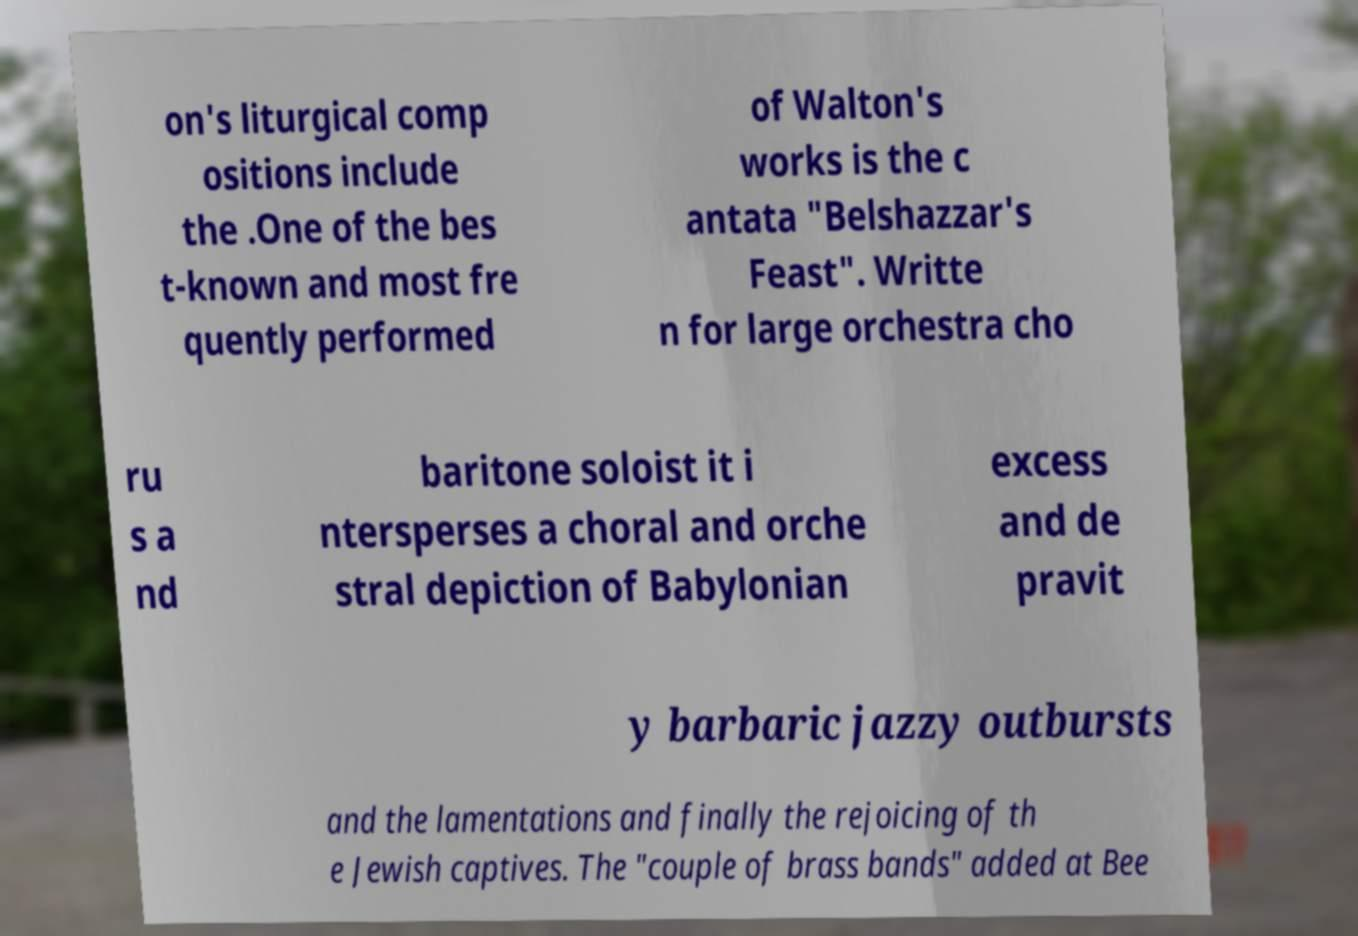Can you read and provide the text displayed in the image?This photo seems to have some interesting text. Can you extract and type it out for me? on's liturgical comp ositions include the .One of the bes t-known and most fre quently performed of Walton's works is the c antata "Belshazzar's Feast". Writte n for large orchestra cho ru s a nd baritone soloist it i ntersperses a choral and orche stral depiction of Babylonian excess and de pravit y barbaric jazzy outbursts and the lamentations and finally the rejoicing of th e Jewish captives. The "couple of brass bands" added at Bee 